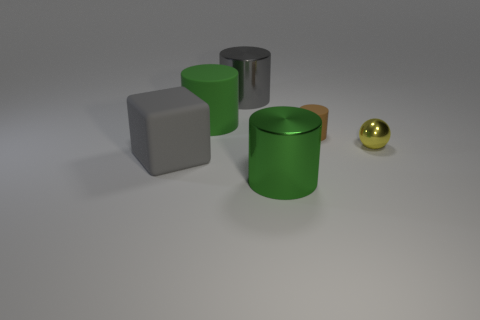Subtract 0 cyan cylinders. How many objects are left? 6 Subtract all spheres. How many objects are left? 5 Subtract 1 cylinders. How many cylinders are left? 3 Subtract all cyan spheres. Subtract all red cylinders. How many spheres are left? 1 Subtract all gray balls. How many cyan cubes are left? 0 Subtract all large yellow rubber cubes. Subtract all small cylinders. How many objects are left? 5 Add 3 green things. How many green things are left? 5 Add 1 gray matte things. How many gray matte things exist? 2 Add 1 gray cylinders. How many objects exist? 7 Subtract all gray cylinders. How many cylinders are left? 3 